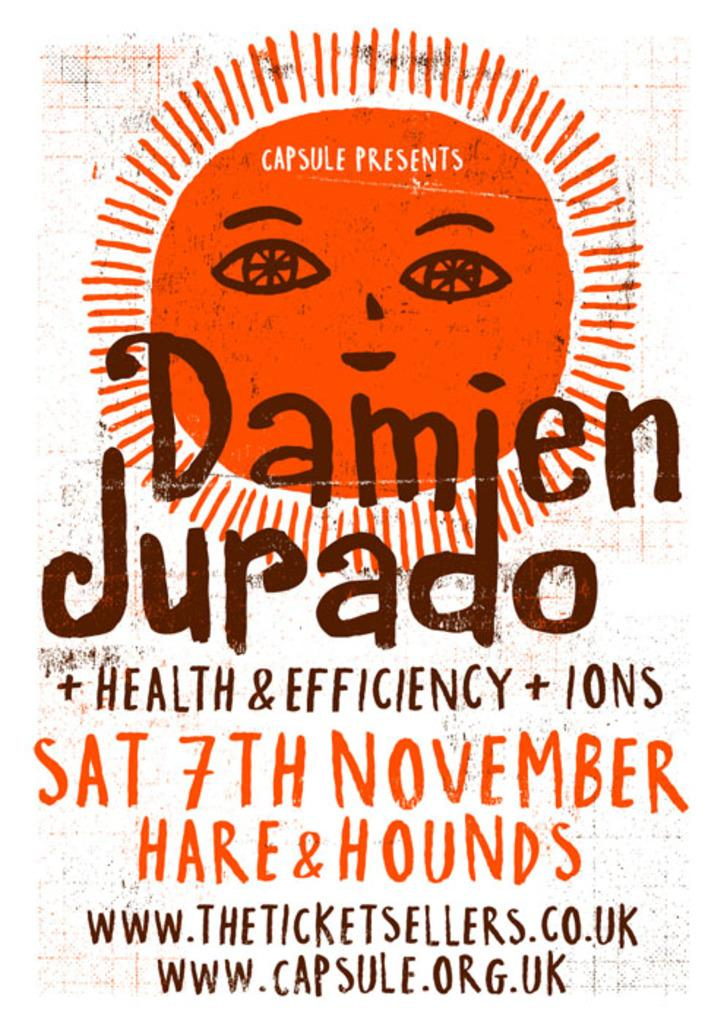<image>
Provide a brief description of the given image. Concert poster for Damien Jurado and Health and Efficiency and others. 